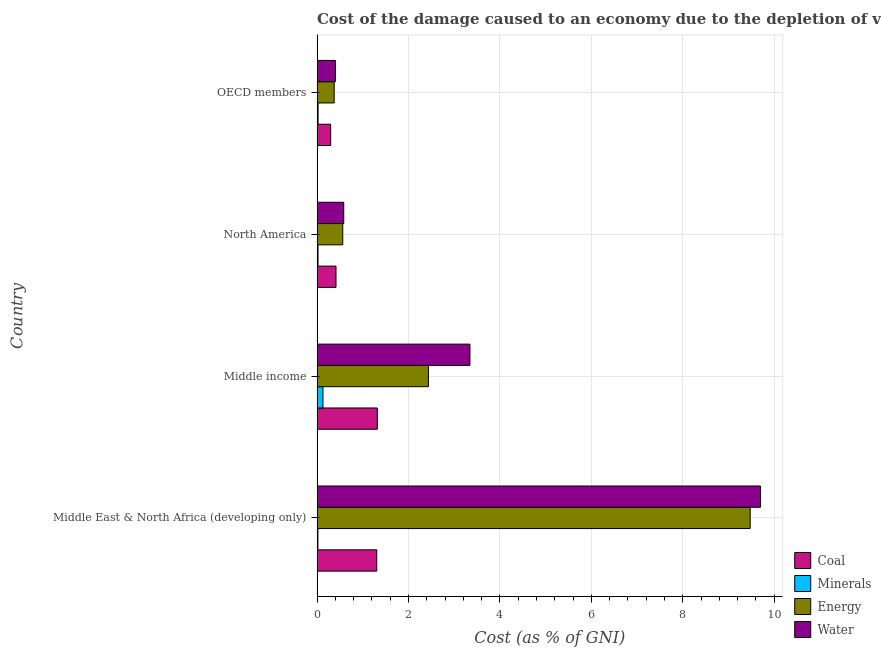How many groups of bars are there?
Make the answer very short. 4. Are the number of bars per tick equal to the number of legend labels?
Give a very brief answer. Yes. How many bars are there on the 1st tick from the top?
Provide a short and direct response. 4. What is the cost of damage due to depletion of energy in North America?
Give a very brief answer. 0.56. Across all countries, what is the maximum cost of damage due to depletion of water?
Your response must be concise. 9.7. Across all countries, what is the minimum cost of damage due to depletion of water?
Your response must be concise. 0.4. What is the total cost of damage due to depletion of energy in the graph?
Keep it short and to the point. 12.85. What is the difference between the cost of damage due to depletion of energy in Middle income and that in OECD members?
Ensure brevity in your answer.  2.06. What is the difference between the cost of damage due to depletion of minerals in Middle income and the cost of damage due to depletion of water in OECD members?
Offer a terse response. -0.27. What is the average cost of damage due to depletion of energy per country?
Give a very brief answer. 3.21. What is the difference between the cost of damage due to depletion of water and cost of damage due to depletion of coal in OECD members?
Your answer should be very brief. 0.1. In how many countries, is the cost of damage due to depletion of water greater than 7.6 %?
Your answer should be very brief. 1. What is the ratio of the cost of damage due to depletion of energy in Middle East & North Africa (developing only) to that in OECD members?
Your answer should be very brief. 25.31. Is the cost of damage due to depletion of water in North America less than that in OECD members?
Offer a terse response. No. What is the difference between the highest and the second highest cost of damage due to depletion of coal?
Ensure brevity in your answer.  0.01. What is the difference between the highest and the lowest cost of damage due to depletion of minerals?
Offer a terse response. 0.11. Is it the case that in every country, the sum of the cost of damage due to depletion of minerals and cost of damage due to depletion of energy is greater than the sum of cost of damage due to depletion of water and cost of damage due to depletion of coal?
Your answer should be compact. No. What does the 4th bar from the top in Middle income represents?
Ensure brevity in your answer.  Coal. What does the 3rd bar from the bottom in OECD members represents?
Provide a short and direct response. Energy. Is it the case that in every country, the sum of the cost of damage due to depletion of coal and cost of damage due to depletion of minerals is greater than the cost of damage due to depletion of energy?
Your answer should be very brief. No. How many countries are there in the graph?
Offer a terse response. 4. What is the difference between two consecutive major ticks on the X-axis?
Make the answer very short. 2. Are the values on the major ticks of X-axis written in scientific E-notation?
Ensure brevity in your answer.  No. What is the title of the graph?
Your answer should be very brief. Cost of the damage caused to an economy due to the depletion of various resources in 1993 . What is the label or title of the X-axis?
Your response must be concise. Cost (as % of GNI). What is the label or title of the Y-axis?
Keep it short and to the point. Country. What is the Cost (as % of GNI) in Coal in Middle East & North Africa (developing only)?
Your answer should be very brief. 1.31. What is the Cost (as % of GNI) in Minerals in Middle East & North Africa (developing only)?
Provide a succinct answer. 0.02. What is the Cost (as % of GNI) of Energy in Middle East & North Africa (developing only)?
Your answer should be compact. 9.48. What is the Cost (as % of GNI) in Water in Middle East & North Africa (developing only)?
Provide a succinct answer. 9.7. What is the Cost (as % of GNI) in Coal in Middle income?
Offer a terse response. 1.32. What is the Cost (as % of GNI) of Minerals in Middle income?
Your answer should be very brief. 0.13. What is the Cost (as % of GNI) in Energy in Middle income?
Your answer should be compact. 2.44. What is the Cost (as % of GNI) in Water in Middle income?
Offer a terse response. 3.34. What is the Cost (as % of GNI) of Coal in North America?
Give a very brief answer. 0.41. What is the Cost (as % of GNI) in Minerals in North America?
Provide a succinct answer. 0.02. What is the Cost (as % of GNI) in Energy in North America?
Provide a short and direct response. 0.56. What is the Cost (as % of GNI) of Water in North America?
Ensure brevity in your answer.  0.58. What is the Cost (as % of GNI) of Coal in OECD members?
Your answer should be compact. 0.3. What is the Cost (as % of GNI) in Minerals in OECD members?
Make the answer very short. 0.02. What is the Cost (as % of GNI) in Energy in OECD members?
Provide a short and direct response. 0.37. What is the Cost (as % of GNI) in Water in OECD members?
Provide a succinct answer. 0.4. Across all countries, what is the maximum Cost (as % of GNI) in Coal?
Give a very brief answer. 1.32. Across all countries, what is the maximum Cost (as % of GNI) in Minerals?
Your response must be concise. 0.13. Across all countries, what is the maximum Cost (as % of GNI) of Energy?
Ensure brevity in your answer.  9.48. Across all countries, what is the maximum Cost (as % of GNI) in Water?
Provide a succinct answer. 9.7. Across all countries, what is the minimum Cost (as % of GNI) of Coal?
Offer a very short reply. 0.3. Across all countries, what is the minimum Cost (as % of GNI) of Minerals?
Offer a terse response. 0.02. Across all countries, what is the minimum Cost (as % of GNI) of Energy?
Your answer should be compact. 0.37. Across all countries, what is the minimum Cost (as % of GNI) of Water?
Offer a terse response. 0.4. What is the total Cost (as % of GNI) of Coal in the graph?
Offer a very short reply. 3.34. What is the total Cost (as % of GNI) in Minerals in the graph?
Offer a terse response. 0.19. What is the total Cost (as % of GNI) in Energy in the graph?
Provide a short and direct response. 12.85. What is the total Cost (as % of GNI) in Water in the graph?
Provide a short and direct response. 14.03. What is the difference between the Cost (as % of GNI) in Coal in Middle East & North Africa (developing only) and that in Middle income?
Ensure brevity in your answer.  -0.01. What is the difference between the Cost (as % of GNI) of Minerals in Middle East & North Africa (developing only) and that in Middle income?
Provide a short and direct response. -0.11. What is the difference between the Cost (as % of GNI) of Energy in Middle East & North Africa (developing only) and that in Middle income?
Your answer should be compact. 7.04. What is the difference between the Cost (as % of GNI) of Water in Middle East & North Africa (developing only) and that in Middle income?
Keep it short and to the point. 6.36. What is the difference between the Cost (as % of GNI) in Coal in Middle East & North Africa (developing only) and that in North America?
Offer a very short reply. 0.89. What is the difference between the Cost (as % of GNI) in Minerals in Middle East & North Africa (developing only) and that in North America?
Make the answer very short. -0. What is the difference between the Cost (as % of GNI) of Energy in Middle East & North Africa (developing only) and that in North America?
Your answer should be very brief. 8.91. What is the difference between the Cost (as % of GNI) in Water in Middle East & North Africa (developing only) and that in North America?
Offer a terse response. 9.12. What is the difference between the Cost (as % of GNI) in Minerals in Middle East & North Africa (developing only) and that in OECD members?
Keep it short and to the point. -0. What is the difference between the Cost (as % of GNI) in Energy in Middle East & North Africa (developing only) and that in OECD members?
Provide a succinct answer. 9.1. What is the difference between the Cost (as % of GNI) in Water in Middle East & North Africa (developing only) and that in OECD members?
Provide a succinct answer. 9.3. What is the difference between the Cost (as % of GNI) of Coal in Middle income and that in North America?
Make the answer very short. 0.9. What is the difference between the Cost (as % of GNI) in Minerals in Middle income and that in North America?
Your response must be concise. 0.11. What is the difference between the Cost (as % of GNI) in Energy in Middle income and that in North America?
Your answer should be compact. 1.87. What is the difference between the Cost (as % of GNI) of Water in Middle income and that in North America?
Keep it short and to the point. 2.76. What is the difference between the Cost (as % of GNI) in Coal in Middle income and that in OECD members?
Offer a terse response. 1.02. What is the difference between the Cost (as % of GNI) of Minerals in Middle income and that in OECD members?
Your answer should be very brief. 0.11. What is the difference between the Cost (as % of GNI) of Energy in Middle income and that in OECD members?
Keep it short and to the point. 2.06. What is the difference between the Cost (as % of GNI) in Water in Middle income and that in OECD members?
Provide a short and direct response. 2.94. What is the difference between the Cost (as % of GNI) in Coal in North America and that in OECD members?
Give a very brief answer. 0.12. What is the difference between the Cost (as % of GNI) of Minerals in North America and that in OECD members?
Provide a succinct answer. -0. What is the difference between the Cost (as % of GNI) of Energy in North America and that in OECD members?
Your response must be concise. 0.19. What is the difference between the Cost (as % of GNI) in Water in North America and that in OECD members?
Your answer should be very brief. 0.18. What is the difference between the Cost (as % of GNI) of Coal in Middle East & North Africa (developing only) and the Cost (as % of GNI) of Minerals in Middle income?
Make the answer very short. 1.18. What is the difference between the Cost (as % of GNI) in Coal in Middle East & North Africa (developing only) and the Cost (as % of GNI) in Energy in Middle income?
Provide a succinct answer. -1.13. What is the difference between the Cost (as % of GNI) of Coal in Middle East & North Africa (developing only) and the Cost (as % of GNI) of Water in Middle income?
Keep it short and to the point. -2.04. What is the difference between the Cost (as % of GNI) of Minerals in Middle East & North Africa (developing only) and the Cost (as % of GNI) of Energy in Middle income?
Keep it short and to the point. -2.42. What is the difference between the Cost (as % of GNI) in Minerals in Middle East & North Africa (developing only) and the Cost (as % of GNI) in Water in Middle income?
Your response must be concise. -3.33. What is the difference between the Cost (as % of GNI) in Energy in Middle East & North Africa (developing only) and the Cost (as % of GNI) in Water in Middle income?
Your response must be concise. 6.13. What is the difference between the Cost (as % of GNI) in Coal in Middle East & North Africa (developing only) and the Cost (as % of GNI) in Minerals in North America?
Provide a short and direct response. 1.28. What is the difference between the Cost (as % of GNI) of Coal in Middle East & North Africa (developing only) and the Cost (as % of GNI) of Energy in North America?
Offer a terse response. 0.74. What is the difference between the Cost (as % of GNI) in Coal in Middle East & North Africa (developing only) and the Cost (as % of GNI) in Water in North America?
Ensure brevity in your answer.  0.72. What is the difference between the Cost (as % of GNI) of Minerals in Middle East & North Africa (developing only) and the Cost (as % of GNI) of Energy in North America?
Keep it short and to the point. -0.54. What is the difference between the Cost (as % of GNI) in Minerals in Middle East & North Africa (developing only) and the Cost (as % of GNI) in Water in North America?
Give a very brief answer. -0.57. What is the difference between the Cost (as % of GNI) in Energy in Middle East & North Africa (developing only) and the Cost (as % of GNI) in Water in North America?
Give a very brief answer. 8.89. What is the difference between the Cost (as % of GNI) of Coal in Middle East & North Africa (developing only) and the Cost (as % of GNI) of Minerals in OECD members?
Ensure brevity in your answer.  1.28. What is the difference between the Cost (as % of GNI) of Coal in Middle East & North Africa (developing only) and the Cost (as % of GNI) of Energy in OECD members?
Offer a terse response. 0.93. What is the difference between the Cost (as % of GNI) of Coal in Middle East & North Africa (developing only) and the Cost (as % of GNI) of Water in OECD members?
Make the answer very short. 0.9. What is the difference between the Cost (as % of GNI) of Minerals in Middle East & North Africa (developing only) and the Cost (as % of GNI) of Energy in OECD members?
Your response must be concise. -0.36. What is the difference between the Cost (as % of GNI) in Minerals in Middle East & North Africa (developing only) and the Cost (as % of GNI) in Water in OECD members?
Give a very brief answer. -0.38. What is the difference between the Cost (as % of GNI) of Energy in Middle East & North Africa (developing only) and the Cost (as % of GNI) of Water in OECD members?
Ensure brevity in your answer.  9.07. What is the difference between the Cost (as % of GNI) of Coal in Middle income and the Cost (as % of GNI) of Minerals in North America?
Give a very brief answer. 1.3. What is the difference between the Cost (as % of GNI) in Coal in Middle income and the Cost (as % of GNI) in Energy in North America?
Your answer should be compact. 0.76. What is the difference between the Cost (as % of GNI) of Coal in Middle income and the Cost (as % of GNI) of Water in North America?
Your answer should be compact. 0.73. What is the difference between the Cost (as % of GNI) in Minerals in Middle income and the Cost (as % of GNI) in Energy in North America?
Offer a very short reply. -0.43. What is the difference between the Cost (as % of GNI) of Minerals in Middle income and the Cost (as % of GNI) of Water in North America?
Provide a short and direct response. -0.45. What is the difference between the Cost (as % of GNI) of Energy in Middle income and the Cost (as % of GNI) of Water in North America?
Offer a terse response. 1.85. What is the difference between the Cost (as % of GNI) of Coal in Middle income and the Cost (as % of GNI) of Minerals in OECD members?
Ensure brevity in your answer.  1.3. What is the difference between the Cost (as % of GNI) of Coal in Middle income and the Cost (as % of GNI) of Energy in OECD members?
Offer a terse response. 0.94. What is the difference between the Cost (as % of GNI) of Coal in Middle income and the Cost (as % of GNI) of Water in OECD members?
Offer a very short reply. 0.92. What is the difference between the Cost (as % of GNI) in Minerals in Middle income and the Cost (as % of GNI) in Energy in OECD members?
Make the answer very short. -0.24. What is the difference between the Cost (as % of GNI) in Minerals in Middle income and the Cost (as % of GNI) in Water in OECD members?
Offer a very short reply. -0.27. What is the difference between the Cost (as % of GNI) in Energy in Middle income and the Cost (as % of GNI) in Water in OECD members?
Your answer should be compact. 2.03. What is the difference between the Cost (as % of GNI) in Coal in North America and the Cost (as % of GNI) in Minerals in OECD members?
Your response must be concise. 0.39. What is the difference between the Cost (as % of GNI) in Coal in North America and the Cost (as % of GNI) in Energy in OECD members?
Provide a succinct answer. 0.04. What is the difference between the Cost (as % of GNI) of Coal in North America and the Cost (as % of GNI) of Water in OECD members?
Keep it short and to the point. 0.01. What is the difference between the Cost (as % of GNI) of Minerals in North America and the Cost (as % of GNI) of Energy in OECD members?
Provide a succinct answer. -0.35. What is the difference between the Cost (as % of GNI) of Minerals in North America and the Cost (as % of GNI) of Water in OECD members?
Ensure brevity in your answer.  -0.38. What is the difference between the Cost (as % of GNI) of Energy in North America and the Cost (as % of GNI) of Water in OECD members?
Provide a succinct answer. 0.16. What is the average Cost (as % of GNI) of Coal per country?
Offer a terse response. 0.83. What is the average Cost (as % of GNI) in Minerals per country?
Provide a succinct answer. 0.05. What is the average Cost (as % of GNI) of Energy per country?
Your answer should be very brief. 3.21. What is the average Cost (as % of GNI) of Water per country?
Ensure brevity in your answer.  3.51. What is the difference between the Cost (as % of GNI) in Coal and Cost (as % of GNI) in Minerals in Middle East & North Africa (developing only)?
Provide a succinct answer. 1.29. What is the difference between the Cost (as % of GNI) in Coal and Cost (as % of GNI) in Energy in Middle East & North Africa (developing only)?
Your answer should be compact. -8.17. What is the difference between the Cost (as % of GNI) in Coal and Cost (as % of GNI) in Water in Middle East & North Africa (developing only)?
Provide a succinct answer. -8.4. What is the difference between the Cost (as % of GNI) in Minerals and Cost (as % of GNI) in Energy in Middle East & North Africa (developing only)?
Your answer should be very brief. -9.46. What is the difference between the Cost (as % of GNI) in Minerals and Cost (as % of GNI) in Water in Middle East & North Africa (developing only)?
Your answer should be compact. -9.68. What is the difference between the Cost (as % of GNI) in Energy and Cost (as % of GNI) in Water in Middle East & North Africa (developing only)?
Provide a succinct answer. -0.23. What is the difference between the Cost (as % of GNI) in Coal and Cost (as % of GNI) in Minerals in Middle income?
Keep it short and to the point. 1.19. What is the difference between the Cost (as % of GNI) in Coal and Cost (as % of GNI) in Energy in Middle income?
Provide a short and direct response. -1.12. What is the difference between the Cost (as % of GNI) of Coal and Cost (as % of GNI) of Water in Middle income?
Offer a very short reply. -2.03. What is the difference between the Cost (as % of GNI) of Minerals and Cost (as % of GNI) of Energy in Middle income?
Offer a terse response. -2.31. What is the difference between the Cost (as % of GNI) in Minerals and Cost (as % of GNI) in Water in Middle income?
Your response must be concise. -3.22. What is the difference between the Cost (as % of GNI) in Energy and Cost (as % of GNI) in Water in Middle income?
Provide a succinct answer. -0.91. What is the difference between the Cost (as % of GNI) in Coal and Cost (as % of GNI) in Minerals in North America?
Provide a succinct answer. 0.39. What is the difference between the Cost (as % of GNI) of Coal and Cost (as % of GNI) of Energy in North America?
Make the answer very short. -0.15. What is the difference between the Cost (as % of GNI) in Coal and Cost (as % of GNI) in Water in North America?
Ensure brevity in your answer.  -0.17. What is the difference between the Cost (as % of GNI) of Minerals and Cost (as % of GNI) of Energy in North America?
Your answer should be compact. -0.54. What is the difference between the Cost (as % of GNI) of Minerals and Cost (as % of GNI) of Water in North America?
Your response must be concise. -0.56. What is the difference between the Cost (as % of GNI) of Energy and Cost (as % of GNI) of Water in North America?
Provide a succinct answer. -0.02. What is the difference between the Cost (as % of GNI) in Coal and Cost (as % of GNI) in Minerals in OECD members?
Provide a succinct answer. 0.28. What is the difference between the Cost (as % of GNI) of Coal and Cost (as % of GNI) of Energy in OECD members?
Your response must be concise. -0.08. What is the difference between the Cost (as % of GNI) in Coal and Cost (as % of GNI) in Water in OECD members?
Ensure brevity in your answer.  -0.1. What is the difference between the Cost (as % of GNI) of Minerals and Cost (as % of GNI) of Energy in OECD members?
Your answer should be very brief. -0.35. What is the difference between the Cost (as % of GNI) in Minerals and Cost (as % of GNI) in Water in OECD members?
Your answer should be compact. -0.38. What is the difference between the Cost (as % of GNI) of Energy and Cost (as % of GNI) of Water in OECD members?
Provide a succinct answer. -0.03. What is the ratio of the Cost (as % of GNI) of Coal in Middle East & North Africa (developing only) to that in Middle income?
Keep it short and to the point. 0.99. What is the ratio of the Cost (as % of GNI) of Minerals in Middle East & North Africa (developing only) to that in Middle income?
Give a very brief answer. 0.14. What is the ratio of the Cost (as % of GNI) of Energy in Middle East & North Africa (developing only) to that in Middle income?
Make the answer very short. 3.89. What is the ratio of the Cost (as % of GNI) in Water in Middle East & North Africa (developing only) to that in Middle income?
Ensure brevity in your answer.  2.9. What is the ratio of the Cost (as % of GNI) of Coal in Middle East & North Africa (developing only) to that in North America?
Ensure brevity in your answer.  3.15. What is the ratio of the Cost (as % of GNI) of Minerals in Middle East & North Africa (developing only) to that in North America?
Your answer should be very brief. 0.89. What is the ratio of the Cost (as % of GNI) of Energy in Middle East & North Africa (developing only) to that in North America?
Keep it short and to the point. 16.84. What is the ratio of the Cost (as % of GNI) of Water in Middle East & North Africa (developing only) to that in North America?
Provide a succinct answer. 16.62. What is the ratio of the Cost (as % of GNI) in Coal in Middle East & North Africa (developing only) to that in OECD members?
Your answer should be compact. 4.38. What is the ratio of the Cost (as % of GNI) of Minerals in Middle East & North Africa (developing only) to that in OECD members?
Your answer should be very brief. 0.84. What is the ratio of the Cost (as % of GNI) of Energy in Middle East & North Africa (developing only) to that in OECD members?
Keep it short and to the point. 25.31. What is the ratio of the Cost (as % of GNI) in Water in Middle East & North Africa (developing only) to that in OECD members?
Offer a terse response. 24.11. What is the ratio of the Cost (as % of GNI) of Coal in Middle income to that in North America?
Ensure brevity in your answer.  3.18. What is the ratio of the Cost (as % of GNI) of Minerals in Middle income to that in North America?
Your answer should be compact. 6.14. What is the ratio of the Cost (as % of GNI) of Energy in Middle income to that in North America?
Your response must be concise. 4.33. What is the ratio of the Cost (as % of GNI) in Water in Middle income to that in North America?
Ensure brevity in your answer.  5.73. What is the ratio of the Cost (as % of GNI) of Coal in Middle income to that in OECD members?
Offer a very short reply. 4.43. What is the ratio of the Cost (as % of GNI) of Minerals in Middle income to that in OECD members?
Give a very brief answer. 5.79. What is the ratio of the Cost (as % of GNI) of Energy in Middle income to that in OECD members?
Provide a succinct answer. 6.51. What is the ratio of the Cost (as % of GNI) of Water in Middle income to that in OECD members?
Ensure brevity in your answer.  8.31. What is the ratio of the Cost (as % of GNI) of Coal in North America to that in OECD members?
Keep it short and to the point. 1.39. What is the ratio of the Cost (as % of GNI) of Minerals in North America to that in OECD members?
Offer a very short reply. 0.94. What is the ratio of the Cost (as % of GNI) of Energy in North America to that in OECD members?
Your response must be concise. 1.5. What is the ratio of the Cost (as % of GNI) of Water in North America to that in OECD members?
Your answer should be very brief. 1.45. What is the difference between the highest and the second highest Cost (as % of GNI) in Coal?
Provide a succinct answer. 0.01. What is the difference between the highest and the second highest Cost (as % of GNI) in Minerals?
Ensure brevity in your answer.  0.11. What is the difference between the highest and the second highest Cost (as % of GNI) of Energy?
Provide a short and direct response. 7.04. What is the difference between the highest and the second highest Cost (as % of GNI) in Water?
Your answer should be compact. 6.36. What is the difference between the highest and the lowest Cost (as % of GNI) in Coal?
Give a very brief answer. 1.02. What is the difference between the highest and the lowest Cost (as % of GNI) of Minerals?
Provide a short and direct response. 0.11. What is the difference between the highest and the lowest Cost (as % of GNI) of Energy?
Provide a succinct answer. 9.1. What is the difference between the highest and the lowest Cost (as % of GNI) in Water?
Offer a very short reply. 9.3. 